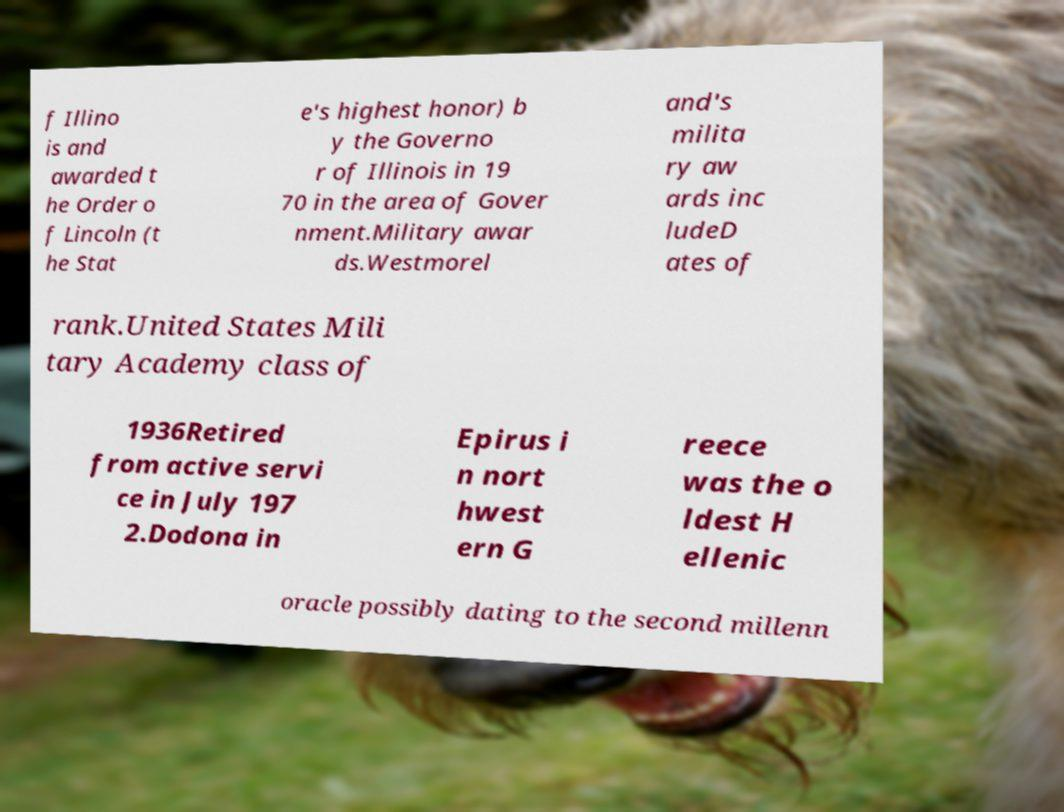Could you extract and type out the text from this image? f Illino is and awarded t he Order o f Lincoln (t he Stat e's highest honor) b y the Governo r of Illinois in 19 70 in the area of Gover nment.Military awar ds.Westmorel and's milita ry aw ards inc ludeD ates of rank.United States Mili tary Academy class of 1936Retired from active servi ce in July 197 2.Dodona in Epirus i n nort hwest ern G reece was the o ldest H ellenic oracle possibly dating to the second millenn 